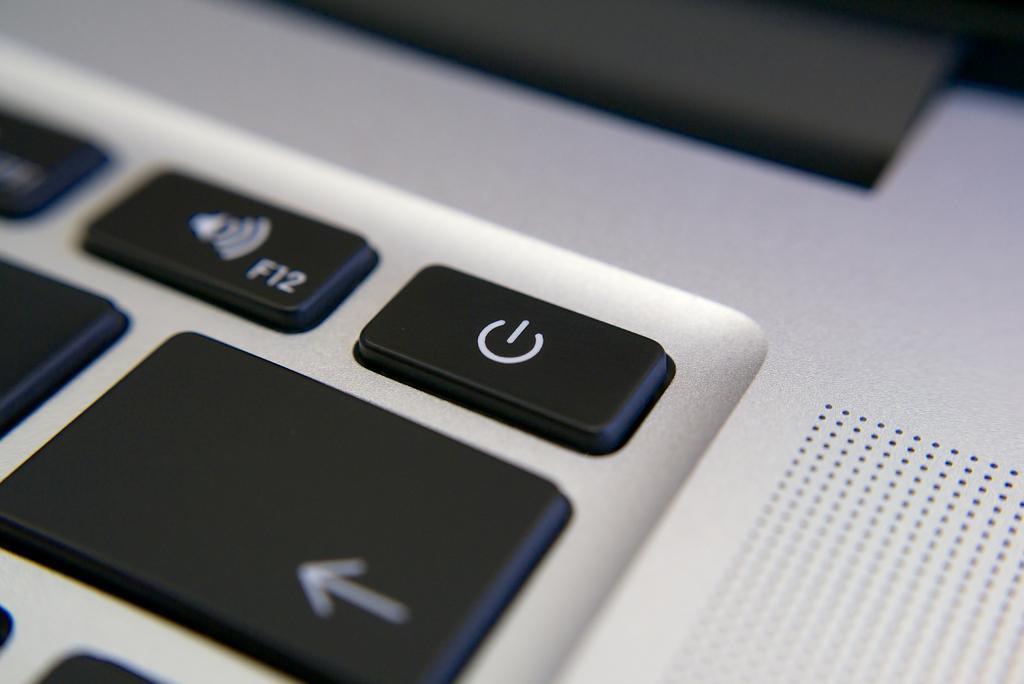How would you summarize this image in a sentence or two? In this image we can see a keyboard. 